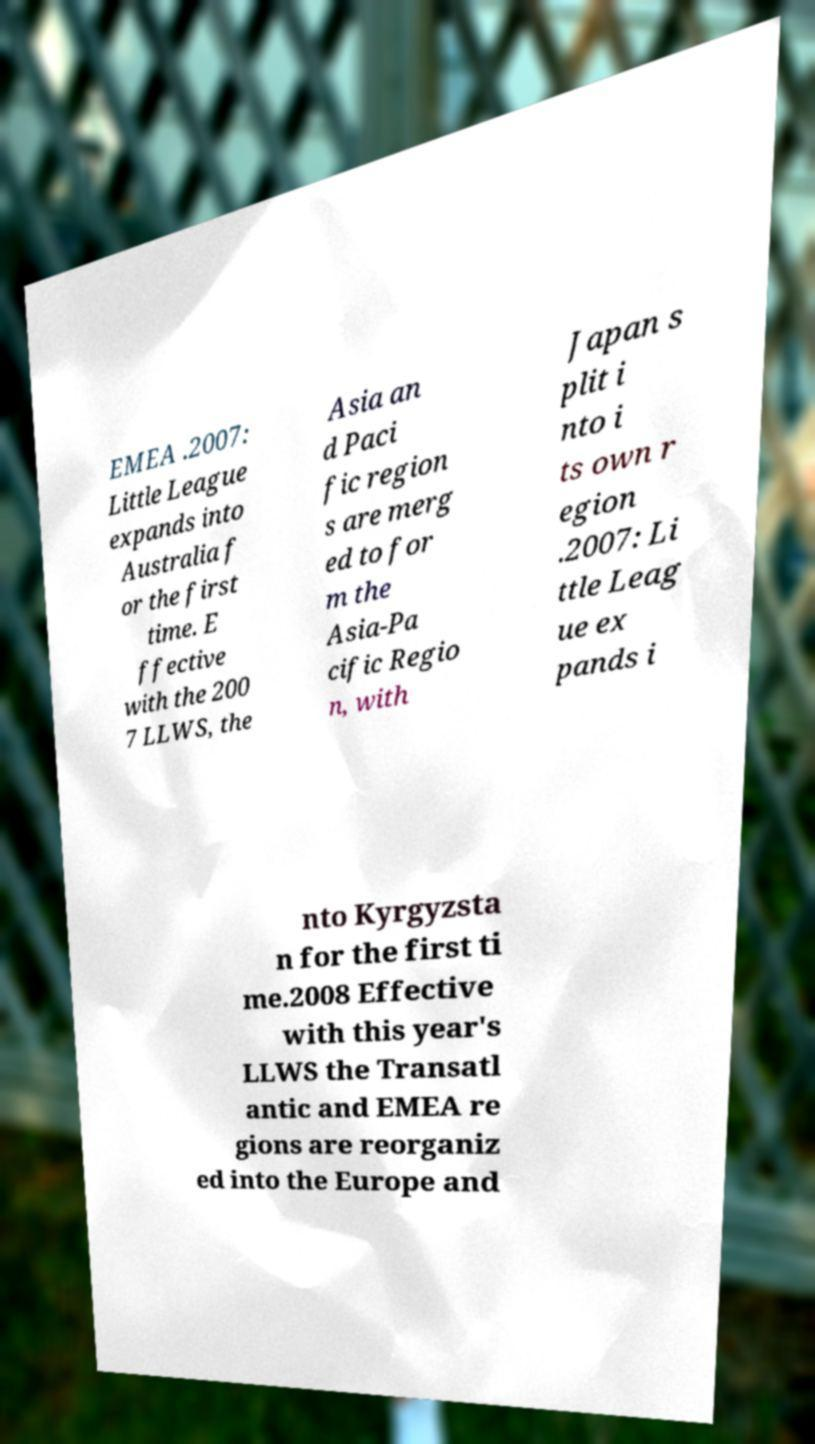What messages or text are displayed in this image? I need them in a readable, typed format. EMEA .2007: Little League expands into Australia f or the first time. E ffective with the 200 7 LLWS, the Asia an d Paci fic region s are merg ed to for m the Asia-Pa cific Regio n, with Japan s plit i nto i ts own r egion .2007: Li ttle Leag ue ex pands i nto Kyrgyzsta n for the first ti me.2008 Effective with this year's LLWS the Transatl antic and EMEA re gions are reorganiz ed into the Europe and 